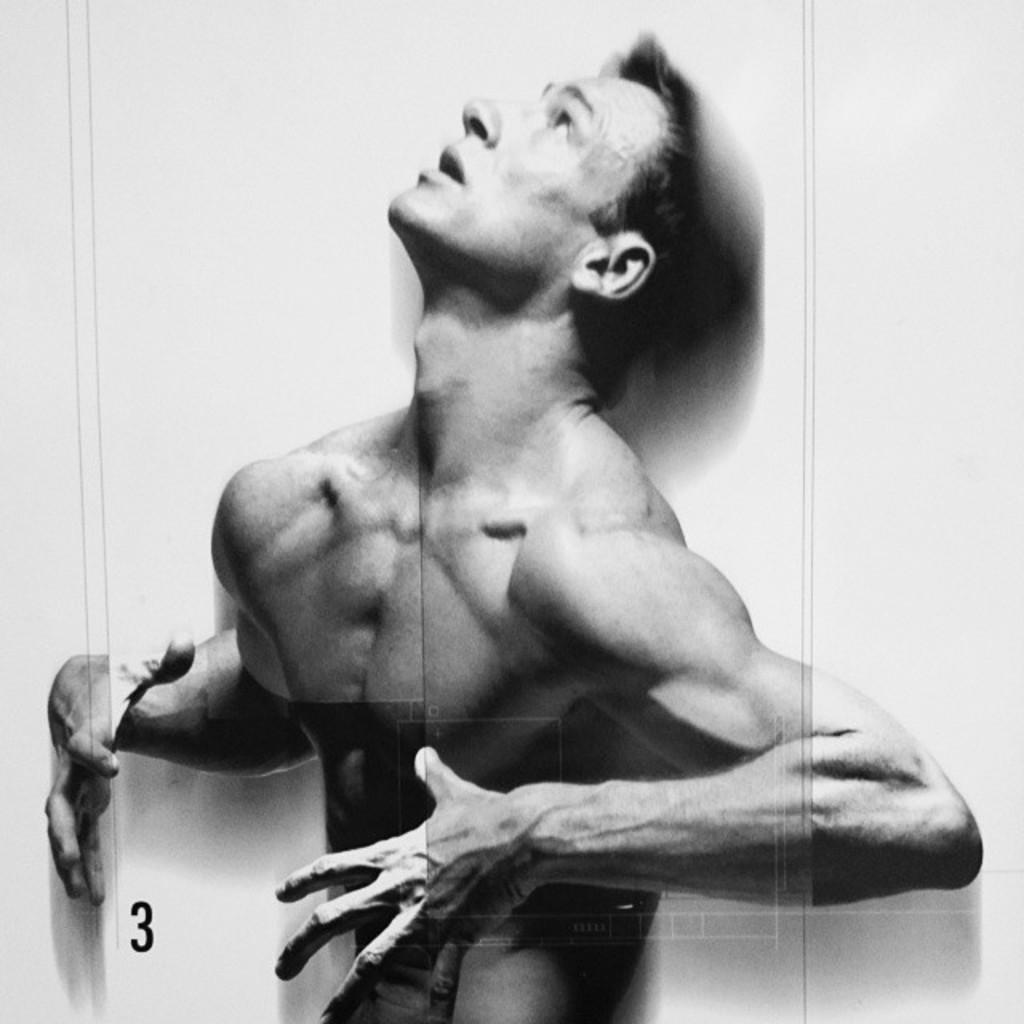What is the color scheme of the image? The image is black and white. Can you describe the main subject of the image? There is a man in the image. What type of plastic object is being used by the man in the image? There is no plastic object visible in the image, as the image is black and white and only shows a man. In which direction is the man facing in the image? The image is black and white, and there is no indication of direction or orientation in the image. 